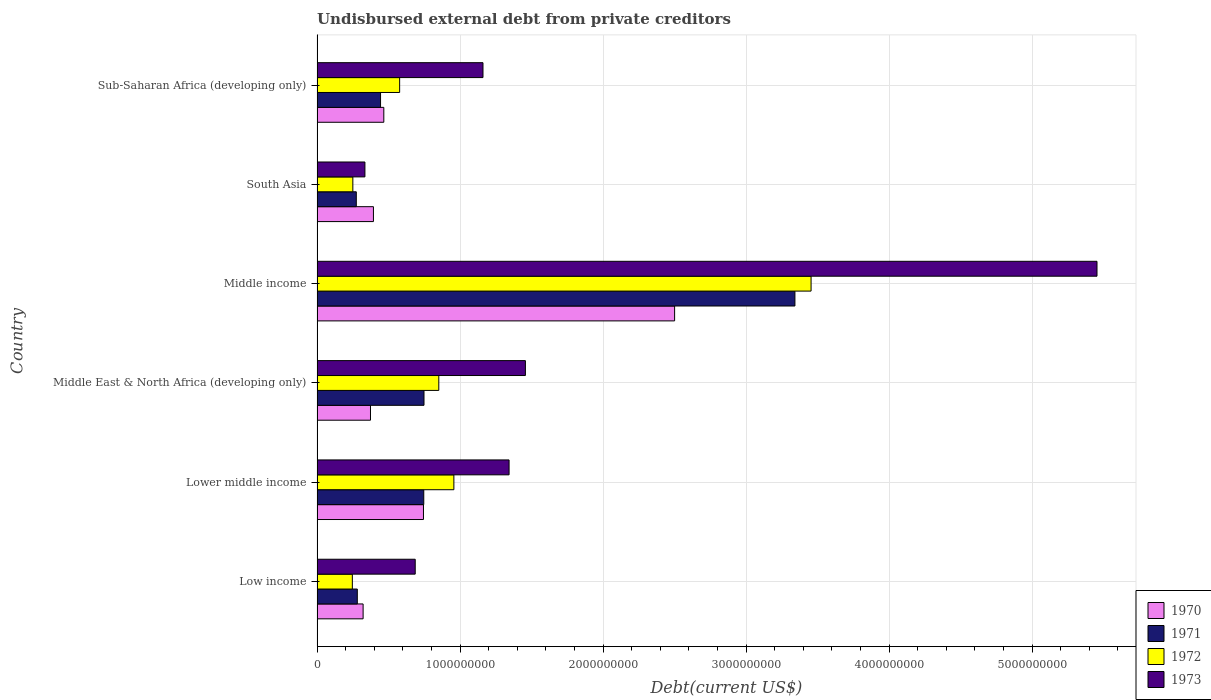Are the number of bars per tick equal to the number of legend labels?
Ensure brevity in your answer.  Yes. How many bars are there on the 1st tick from the top?
Offer a very short reply. 4. How many bars are there on the 4th tick from the bottom?
Your answer should be very brief. 4. What is the label of the 5th group of bars from the top?
Ensure brevity in your answer.  Lower middle income. What is the total debt in 1973 in South Asia?
Keep it short and to the point. 3.35e+08. Across all countries, what is the maximum total debt in 1971?
Give a very brief answer. 3.34e+09. Across all countries, what is the minimum total debt in 1972?
Make the answer very short. 2.47e+08. In which country was the total debt in 1972 minimum?
Your answer should be compact. Low income. What is the total total debt in 1971 in the graph?
Make the answer very short. 5.84e+09. What is the difference between the total debt in 1973 in Low income and that in Middle income?
Your response must be concise. -4.77e+09. What is the difference between the total debt in 1972 in Lower middle income and the total debt in 1970 in Middle income?
Offer a very short reply. -1.54e+09. What is the average total debt in 1973 per country?
Make the answer very short. 1.74e+09. What is the difference between the total debt in 1973 and total debt in 1970 in Sub-Saharan Africa (developing only)?
Offer a terse response. 6.94e+08. In how many countries, is the total debt in 1973 greater than 2800000000 US$?
Offer a very short reply. 1. What is the ratio of the total debt in 1973 in Lower middle income to that in Sub-Saharan Africa (developing only)?
Make the answer very short. 1.16. Is the difference between the total debt in 1973 in Middle East & North Africa (developing only) and Sub-Saharan Africa (developing only) greater than the difference between the total debt in 1970 in Middle East & North Africa (developing only) and Sub-Saharan Africa (developing only)?
Give a very brief answer. Yes. What is the difference between the highest and the second highest total debt in 1973?
Your answer should be very brief. 4.00e+09. What is the difference between the highest and the lowest total debt in 1972?
Your response must be concise. 3.21e+09. In how many countries, is the total debt in 1972 greater than the average total debt in 1972 taken over all countries?
Your answer should be compact. 1. Is the sum of the total debt in 1970 in Middle income and South Asia greater than the maximum total debt in 1971 across all countries?
Offer a very short reply. No. What does the 2nd bar from the bottom in Middle income represents?
Your response must be concise. 1971. What is the difference between two consecutive major ticks on the X-axis?
Offer a very short reply. 1.00e+09. Where does the legend appear in the graph?
Your answer should be very brief. Bottom right. How many legend labels are there?
Your answer should be very brief. 4. How are the legend labels stacked?
Make the answer very short. Vertical. What is the title of the graph?
Give a very brief answer. Undisbursed external debt from private creditors. What is the label or title of the X-axis?
Keep it short and to the point. Debt(current US$). What is the Debt(current US$) of 1970 in Low income?
Make the answer very short. 3.22e+08. What is the Debt(current US$) of 1971 in Low income?
Your response must be concise. 2.82e+08. What is the Debt(current US$) in 1972 in Low income?
Provide a short and direct response. 2.47e+08. What is the Debt(current US$) in 1973 in Low income?
Keep it short and to the point. 6.86e+08. What is the Debt(current US$) in 1970 in Lower middle income?
Ensure brevity in your answer.  7.44e+08. What is the Debt(current US$) of 1971 in Lower middle income?
Offer a very short reply. 7.46e+08. What is the Debt(current US$) in 1972 in Lower middle income?
Make the answer very short. 9.57e+08. What is the Debt(current US$) in 1973 in Lower middle income?
Your response must be concise. 1.34e+09. What is the Debt(current US$) in 1970 in Middle East & North Africa (developing only)?
Provide a short and direct response. 3.74e+08. What is the Debt(current US$) in 1971 in Middle East & North Africa (developing only)?
Provide a succinct answer. 7.48e+08. What is the Debt(current US$) in 1972 in Middle East & North Africa (developing only)?
Offer a very short reply. 8.51e+08. What is the Debt(current US$) in 1973 in Middle East & North Africa (developing only)?
Your answer should be compact. 1.46e+09. What is the Debt(current US$) of 1970 in Middle income?
Your response must be concise. 2.50e+09. What is the Debt(current US$) in 1971 in Middle income?
Provide a short and direct response. 3.34e+09. What is the Debt(current US$) of 1972 in Middle income?
Ensure brevity in your answer.  3.45e+09. What is the Debt(current US$) in 1973 in Middle income?
Provide a short and direct response. 5.45e+09. What is the Debt(current US$) of 1970 in South Asia?
Offer a very short reply. 3.94e+08. What is the Debt(current US$) of 1971 in South Asia?
Your response must be concise. 2.74e+08. What is the Debt(current US$) of 1972 in South Asia?
Your response must be concise. 2.50e+08. What is the Debt(current US$) of 1973 in South Asia?
Your response must be concise. 3.35e+08. What is the Debt(current US$) in 1970 in Sub-Saharan Africa (developing only)?
Offer a terse response. 4.67e+08. What is the Debt(current US$) of 1971 in Sub-Saharan Africa (developing only)?
Your response must be concise. 4.44e+08. What is the Debt(current US$) of 1972 in Sub-Saharan Africa (developing only)?
Offer a very short reply. 5.77e+08. What is the Debt(current US$) of 1973 in Sub-Saharan Africa (developing only)?
Keep it short and to the point. 1.16e+09. Across all countries, what is the maximum Debt(current US$) of 1970?
Offer a terse response. 2.50e+09. Across all countries, what is the maximum Debt(current US$) of 1971?
Give a very brief answer. 3.34e+09. Across all countries, what is the maximum Debt(current US$) in 1972?
Keep it short and to the point. 3.45e+09. Across all countries, what is the maximum Debt(current US$) of 1973?
Offer a terse response. 5.45e+09. Across all countries, what is the minimum Debt(current US$) in 1970?
Offer a very short reply. 3.22e+08. Across all countries, what is the minimum Debt(current US$) in 1971?
Your answer should be very brief. 2.74e+08. Across all countries, what is the minimum Debt(current US$) in 1972?
Keep it short and to the point. 2.47e+08. Across all countries, what is the minimum Debt(current US$) of 1973?
Provide a short and direct response. 3.35e+08. What is the total Debt(current US$) of 1970 in the graph?
Make the answer very short. 4.80e+09. What is the total Debt(current US$) of 1971 in the graph?
Your answer should be very brief. 5.84e+09. What is the total Debt(current US$) in 1972 in the graph?
Provide a short and direct response. 6.34e+09. What is the total Debt(current US$) of 1973 in the graph?
Offer a very short reply. 1.04e+1. What is the difference between the Debt(current US$) of 1970 in Low income and that in Lower middle income?
Offer a terse response. -4.22e+08. What is the difference between the Debt(current US$) in 1971 in Low income and that in Lower middle income?
Your answer should be compact. -4.65e+08. What is the difference between the Debt(current US$) of 1972 in Low income and that in Lower middle income?
Offer a terse response. -7.10e+08. What is the difference between the Debt(current US$) of 1973 in Low income and that in Lower middle income?
Keep it short and to the point. -6.56e+08. What is the difference between the Debt(current US$) of 1970 in Low income and that in Middle East & North Africa (developing only)?
Ensure brevity in your answer.  -5.15e+07. What is the difference between the Debt(current US$) of 1971 in Low income and that in Middle East & North Africa (developing only)?
Offer a very short reply. -4.66e+08. What is the difference between the Debt(current US$) in 1972 in Low income and that in Middle East & North Africa (developing only)?
Offer a very short reply. -6.05e+08. What is the difference between the Debt(current US$) of 1973 in Low income and that in Middle East & North Africa (developing only)?
Your response must be concise. -7.71e+08. What is the difference between the Debt(current US$) of 1970 in Low income and that in Middle income?
Your response must be concise. -2.18e+09. What is the difference between the Debt(current US$) in 1971 in Low income and that in Middle income?
Your answer should be very brief. -3.06e+09. What is the difference between the Debt(current US$) in 1972 in Low income and that in Middle income?
Your answer should be compact. -3.21e+09. What is the difference between the Debt(current US$) of 1973 in Low income and that in Middle income?
Provide a succinct answer. -4.77e+09. What is the difference between the Debt(current US$) in 1970 in Low income and that in South Asia?
Ensure brevity in your answer.  -7.22e+07. What is the difference between the Debt(current US$) of 1971 in Low income and that in South Asia?
Your answer should be compact. 7.14e+06. What is the difference between the Debt(current US$) of 1972 in Low income and that in South Asia?
Ensure brevity in your answer.  -3.44e+06. What is the difference between the Debt(current US$) in 1973 in Low income and that in South Asia?
Give a very brief answer. 3.52e+08. What is the difference between the Debt(current US$) in 1970 in Low income and that in Sub-Saharan Africa (developing only)?
Offer a very short reply. -1.45e+08. What is the difference between the Debt(current US$) in 1971 in Low income and that in Sub-Saharan Africa (developing only)?
Provide a succinct answer. -1.63e+08. What is the difference between the Debt(current US$) in 1972 in Low income and that in Sub-Saharan Africa (developing only)?
Offer a very short reply. -3.31e+08. What is the difference between the Debt(current US$) of 1973 in Low income and that in Sub-Saharan Africa (developing only)?
Ensure brevity in your answer.  -4.74e+08. What is the difference between the Debt(current US$) in 1970 in Lower middle income and that in Middle East & North Africa (developing only)?
Make the answer very short. 3.71e+08. What is the difference between the Debt(current US$) of 1971 in Lower middle income and that in Middle East & North Africa (developing only)?
Keep it short and to the point. -1.62e+06. What is the difference between the Debt(current US$) of 1972 in Lower middle income and that in Middle East & North Africa (developing only)?
Provide a succinct answer. 1.05e+08. What is the difference between the Debt(current US$) in 1973 in Lower middle income and that in Middle East & North Africa (developing only)?
Your answer should be very brief. -1.14e+08. What is the difference between the Debt(current US$) of 1970 in Lower middle income and that in Middle income?
Offer a terse response. -1.76e+09. What is the difference between the Debt(current US$) in 1971 in Lower middle income and that in Middle income?
Make the answer very short. -2.60e+09. What is the difference between the Debt(current US$) in 1972 in Lower middle income and that in Middle income?
Your response must be concise. -2.50e+09. What is the difference between the Debt(current US$) in 1973 in Lower middle income and that in Middle income?
Provide a succinct answer. -4.11e+09. What is the difference between the Debt(current US$) in 1970 in Lower middle income and that in South Asia?
Ensure brevity in your answer.  3.50e+08. What is the difference between the Debt(current US$) in 1971 in Lower middle income and that in South Asia?
Keep it short and to the point. 4.72e+08. What is the difference between the Debt(current US$) in 1972 in Lower middle income and that in South Asia?
Provide a short and direct response. 7.07e+08. What is the difference between the Debt(current US$) of 1973 in Lower middle income and that in South Asia?
Offer a very short reply. 1.01e+09. What is the difference between the Debt(current US$) in 1970 in Lower middle income and that in Sub-Saharan Africa (developing only)?
Give a very brief answer. 2.77e+08. What is the difference between the Debt(current US$) of 1971 in Lower middle income and that in Sub-Saharan Africa (developing only)?
Provide a succinct answer. 3.02e+08. What is the difference between the Debt(current US$) in 1972 in Lower middle income and that in Sub-Saharan Africa (developing only)?
Make the answer very short. 3.79e+08. What is the difference between the Debt(current US$) of 1973 in Lower middle income and that in Sub-Saharan Africa (developing only)?
Your answer should be very brief. 1.82e+08. What is the difference between the Debt(current US$) of 1970 in Middle East & North Africa (developing only) and that in Middle income?
Provide a succinct answer. -2.13e+09. What is the difference between the Debt(current US$) of 1971 in Middle East & North Africa (developing only) and that in Middle income?
Provide a short and direct response. -2.59e+09. What is the difference between the Debt(current US$) of 1972 in Middle East & North Africa (developing only) and that in Middle income?
Offer a terse response. -2.60e+09. What is the difference between the Debt(current US$) in 1973 in Middle East & North Africa (developing only) and that in Middle income?
Provide a short and direct response. -4.00e+09. What is the difference between the Debt(current US$) in 1970 in Middle East & North Africa (developing only) and that in South Asia?
Make the answer very short. -2.07e+07. What is the difference between the Debt(current US$) of 1971 in Middle East & North Africa (developing only) and that in South Asia?
Keep it short and to the point. 4.74e+08. What is the difference between the Debt(current US$) of 1972 in Middle East & North Africa (developing only) and that in South Asia?
Offer a terse response. 6.01e+08. What is the difference between the Debt(current US$) of 1973 in Middle East & North Africa (developing only) and that in South Asia?
Your answer should be very brief. 1.12e+09. What is the difference between the Debt(current US$) in 1970 in Middle East & North Africa (developing only) and that in Sub-Saharan Africa (developing only)?
Offer a terse response. -9.32e+07. What is the difference between the Debt(current US$) in 1971 in Middle East & North Africa (developing only) and that in Sub-Saharan Africa (developing only)?
Your answer should be very brief. 3.04e+08. What is the difference between the Debt(current US$) in 1972 in Middle East & North Africa (developing only) and that in Sub-Saharan Africa (developing only)?
Provide a short and direct response. 2.74e+08. What is the difference between the Debt(current US$) in 1973 in Middle East & North Africa (developing only) and that in Sub-Saharan Africa (developing only)?
Your answer should be very brief. 2.97e+08. What is the difference between the Debt(current US$) of 1970 in Middle income and that in South Asia?
Offer a very short reply. 2.11e+09. What is the difference between the Debt(current US$) of 1971 in Middle income and that in South Asia?
Give a very brief answer. 3.07e+09. What is the difference between the Debt(current US$) of 1972 in Middle income and that in South Asia?
Your answer should be compact. 3.20e+09. What is the difference between the Debt(current US$) in 1973 in Middle income and that in South Asia?
Provide a short and direct response. 5.12e+09. What is the difference between the Debt(current US$) of 1970 in Middle income and that in Sub-Saharan Africa (developing only)?
Your answer should be compact. 2.03e+09. What is the difference between the Debt(current US$) in 1971 in Middle income and that in Sub-Saharan Africa (developing only)?
Provide a short and direct response. 2.90e+09. What is the difference between the Debt(current US$) of 1972 in Middle income and that in Sub-Saharan Africa (developing only)?
Provide a short and direct response. 2.88e+09. What is the difference between the Debt(current US$) of 1973 in Middle income and that in Sub-Saharan Africa (developing only)?
Your answer should be compact. 4.29e+09. What is the difference between the Debt(current US$) of 1970 in South Asia and that in Sub-Saharan Africa (developing only)?
Your answer should be very brief. -7.26e+07. What is the difference between the Debt(current US$) of 1971 in South Asia and that in Sub-Saharan Africa (developing only)?
Give a very brief answer. -1.70e+08. What is the difference between the Debt(current US$) of 1972 in South Asia and that in Sub-Saharan Africa (developing only)?
Keep it short and to the point. -3.27e+08. What is the difference between the Debt(current US$) of 1973 in South Asia and that in Sub-Saharan Africa (developing only)?
Provide a short and direct response. -8.26e+08. What is the difference between the Debt(current US$) in 1970 in Low income and the Debt(current US$) in 1971 in Lower middle income?
Provide a short and direct response. -4.24e+08. What is the difference between the Debt(current US$) of 1970 in Low income and the Debt(current US$) of 1972 in Lower middle income?
Make the answer very short. -6.35e+08. What is the difference between the Debt(current US$) of 1970 in Low income and the Debt(current US$) of 1973 in Lower middle income?
Your answer should be compact. -1.02e+09. What is the difference between the Debt(current US$) in 1971 in Low income and the Debt(current US$) in 1972 in Lower middle income?
Provide a short and direct response. -6.75e+08. What is the difference between the Debt(current US$) in 1971 in Low income and the Debt(current US$) in 1973 in Lower middle income?
Keep it short and to the point. -1.06e+09. What is the difference between the Debt(current US$) in 1972 in Low income and the Debt(current US$) in 1973 in Lower middle income?
Your answer should be compact. -1.10e+09. What is the difference between the Debt(current US$) in 1970 in Low income and the Debt(current US$) in 1971 in Middle East & North Africa (developing only)?
Provide a succinct answer. -4.26e+08. What is the difference between the Debt(current US$) in 1970 in Low income and the Debt(current US$) in 1972 in Middle East & North Africa (developing only)?
Provide a short and direct response. -5.29e+08. What is the difference between the Debt(current US$) in 1970 in Low income and the Debt(current US$) in 1973 in Middle East & North Africa (developing only)?
Offer a terse response. -1.13e+09. What is the difference between the Debt(current US$) of 1971 in Low income and the Debt(current US$) of 1972 in Middle East & North Africa (developing only)?
Your answer should be very brief. -5.70e+08. What is the difference between the Debt(current US$) of 1971 in Low income and the Debt(current US$) of 1973 in Middle East & North Africa (developing only)?
Your answer should be compact. -1.18e+09. What is the difference between the Debt(current US$) of 1972 in Low income and the Debt(current US$) of 1973 in Middle East & North Africa (developing only)?
Your answer should be compact. -1.21e+09. What is the difference between the Debt(current US$) in 1970 in Low income and the Debt(current US$) in 1971 in Middle income?
Give a very brief answer. -3.02e+09. What is the difference between the Debt(current US$) of 1970 in Low income and the Debt(current US$) of 1972 in Middle income?
Make the answer very short. -3.13e+09. What is the difference between the Debt(current US$) of 1970 in Low income and the Debt(current US$) of 1973 in Middle income?
Make the answer very short. -5.13e+09. What is the difference between the Debt(current US$) of 1971 in Low income and the Debt(current US$) of 1972 in Middle income?
Your response must be concise. -3.17e+09. What is the difference between the Debt(current US$) in 1971 in Low income and the Debt(current US$) in 1973 in Middle income?
Make the answer very short. -5.17e+09. What is the difference between the Debt(current US$) in 1972 in Low income and the Debt(current US$) in 1973 in Middle income?
Keep it short and to the point. -5.21e+09. What is the difference between the Debt(current US$) of 1970 in Low income and the Debt(current US$) of 1971 in South Asia?
Provide a short and direct response. 4.77e+07. What is the difference between the Debt(current US$) of 1970 in Low income and the Debt(current US$) of 1972 in South Asia?
Ensure brevity in your answer.  7.18e+07. What is the difference between the Debt(current US$) in 1970 in Low income and the Debt(current US$) in 1973 in South Asia?
Give a very brief answer. -1.27e+07. What is the difference between the Debt(current US$) in 1971 in Low income and the Debt(current US$) in 1972 in South Asia?
Offer a terse response. 3.13e+07. What is the difference between the Debt(current US$) in 1971 in Low income and the Debt(current US$) in 1973 in South Asia?
Make the answer very short. -5.33e+07. What is the difference between the Debt(current US$) of 1972 in Low income and the Debt(current US$) of 1973 in South Asia?
Provide a succinct answer. -8.80e+07. What is the difference between the Debt(current US$) of 1970 in Low income and the Debt(current US$) of 1971 in Sub-Saharan Africa (developing only)?
Your response must be concise. -1.22e+08. What is the difference between the Debt(current US$) of 1970 in Low income and the Debt(current US$) of 1972 in Sub-Saharan Africa (developing only)?
Keep it short and to the point. -2.55e+08. What is the difference between the Debt(current US$) in 1970 in Low income and the Debt(current US$) in 1973 in Sub-Saharan Africa (developing only)?
Keep it short and to the point. -8.38e+08. What is the difference between the Debt(current US$) in 1971 in Low income and the Debt(current US$) in 1972 in Sub-Saharan Africa (developing only)?
Ensure brevity in your answer.  -2.96e+08. What is the difference between the Debt(current US$) of 1971 in Low income and the Debt(current US$) of 1973 in Sub-Saharan Africa (developing only)?
Ensure brevity in your answer.  -8.79e+08. What is the difference between the Debt(current US$) in 1972 in Low income and the Debt(current US$) in 1973 in Sub-Saharan Africa (developing only)?
Your answer should be compact. -9.14e+08. What is the difference between the Debt(current US$) in 1970 in Lower middle income and the Debt(current US$) in 1971 in Middle East & North Africa (developing only)?
Make the answer very short. -3.71e+06. What is the difference between the Debt(current US$) in 1970 in Lower middle income and the Debt(current US$) in 1972 in Middle East & North Africa (developing only)?
Give a very brief answer. -1.07e+08. What is the difference between the Debt(current US$) of 1970 in Lower middle income and the Debt(current US$) of 1973 in Middle East & North Africa (developing only)?
Keep it short and to the point. -7.13e+08. What is the difference between the Debt(current US$) of 1971 in Lower middle income and the Debt(current US$) of 1972 in Middle East & North Africa (developing only)?
Provide a short and direct response. -1.05e+08. What is the difference between the Debt(current US$) in 1971 in Lower middle income and the Debt(current US$) in 1973 in Middle East & North Africa (developing only)?
Offer a terse response. -7.11e+08. What is the difference between the Debt(current US$) in 1972 in Lower middle income and the Debt(current US$) in 1973 in Middle East & North Africa (developing only)?
Your answer should be compact. -5.00e+08. What is the difference between the Debt(current US$) of 1970 in Lower middle income and the Debt(current US$) of 1971 in Middle income?
Your answer should be very brief. -2.60e+09. What is the difference between the Debt(current US$) in 1970 in Lower middle income and the Debt(current US$) in 1972 in Middle income?
Make the answer very short. -2.71e+09. What is the difference between the Debt(current US$) of 1970 in Lower middle income and the Debt(current US$) of 1973 in Middle income?
Provide a short and direct response. -4.71e+09. What is the difference between the Debt(current US$) of 1971 in Lower middle income and the Debt(current US$) of 1972 in Middle income?
Provide a short and direct response. -2.71e+09. What is the difference between the Debt(current US$) of 1971 in Lower middle income and the Debt(current US$) of 1973 in Middle income?
Your answer should be compact. -4.71e+09. What is the difference between the Debt(current US$) in 1972 in Lower middle income and the Debt(current US$) in 1973 in Middle income?
Your response must be concise. -4.50e+09. What is the difference between the Debt(current US$) in 1970 in Lower middle income and the Debt(current US$) in 1971 in South Asia?
Offer a terse response. 4.70e+08. What is the difference between the Debt(current US$) of 1970 in Lower middle income and the Debt(current US$) of 1972 in South Asia?
Offer a terse response. 4.94e+08. What is the difference between the Debt(current US$) of 1970 in Lower middle income and the Debt(current US$) of 1973 in South Asia?
Your answer should be very brief. 4.09e+08. What is the difference between the Debt(current US$) in 1971 in Lower middle income and the Debt(current US$) in 1972 in South Asia?
Offer a very short reply. 4.96e+08. What is the difference between the Debt(current US$) in 1971 in Lower middle income and the Debt(current US$) in 1973 in South Asia?
Give a very brief answer. 4.11e+08. What is the difference between the Debt(current US$) in 1972 in Lower middle income and the Debt(current US$) in 1973 in South Asia?
Provide a succinct answer. 6.22e+08. What is the difference between the Debt(current US$) in 1970 in Lower middle income and the Debt(current US$) in 1971 in Sub-Saharan Africa (developing only)?
Keep it short and to the point. 3.00e+08. What is the difference between the Debt(current US$) of 1970 in Lower middle income and the Debt(current US$) of 1972 in Sub-Saharan Africa (developing only)?
Give a very brief answer. 1.67e+08. What is the difference between the Debt(current US$) in 1970 in Lower middle income and the Debt(current US$) in 1973 in Sub-Saharan Africa (developing only)?
Make the answer very short. -4.16e+08. What is the difference between the Debt(current US$) of 1971 in Lower middle income and the Debt(current US$) of 1972 in Sub-Saharan Africa (developing only)?
Provide a succinct answer. 1.69e+08. What is the difference between the Debt(current US$) in 1971 in Lower middle income and the Debt(current US$) in 1973 in Sub-Saharan Africa (developing only)?
Provide a succinct answer. -4.14e+08. What is the difference between the Debt(current US$) in 1972 in Lower middle income and the Debt(current US$) in 1973 in Sub-Saharan Africa (developing only)?
Your answer should be very brief. -2.04e+08. What is the difference between the Debt(current US$) of 1970 in Middle East & North Africa (developing only) and the Debt(current US$) of 1971 in Middle income?
Keep it short and to the point. -2.97e+09. What is the difference between the Debt(current US$) of 1970 in Middle East & North Africa (developing only) and the Debt(current US$) of 1972 in Middle income?
Provide a succinct answer. -3.08e+09. What is the difference between the Debt(current US$) in 1970 in Middle East & North Africa (developing only) and the Debt(current US$) in 1973 in Middle income?
Give a very brief answer. -5.08e+09. What is the difference between the Debt(current US$) of 1971 in Middle East & North Africa (developing only) and the Debt(current US$) of 1972 in Middle income?
Your answer should be compact. -2.71e+09. What is the difference between the Debt(current US$) of 1971 in Middle East & North Africa (developing only) and the Debt(current US$) of 1973 in Middle income?
Offer a very short reply. -4.71e+09. What is the difference between the Debt(current US$) in 1972 in Middle East & North Africa (developing only) and the Debt(current US$) in 1973 in Middle income?
Your answer should be very brief. -4.60e+09. What is the difference between the Debt(current US$) of 1970 in Middle East & North Africa (developing only) and the Debt(current US$) of 1971 in South Asia?
Your response must be concise. 9.92e+07. What is the difference between the Debt(current US$) in 1970 in Middle East & North Africa (developing only) and the Debt(current US$) in 1972 in South Asia?
Make the answer very short. 1.23e+08. What is the difference between the Debt(current US$) of 1970 in Middle East & North Africa (developing only) and the Debt(current US$) of 1973 in South Asia?
Your answer should be very brief. 3.88e+07. What is the difference between the Debt(current US$) of 1971 in Middle East & North Africa (developing only) and the Debt(current US$) of 1972 in South Asia?
Provide a succinct answer. 4.98e+08. What is the difference between the Debt(current US$) in 1971 in Middle East & North Africa (developing only) and the Debt(current US$) in 1973 in South Asia?
Keep it short and to the point. 4.13e+08. What is the difference between the Debt(current US$) of 1972 in Middle East & North Africa (developing only) and the Debt(current US$) of 1973 in South Asia?
Provide a succinct answer. 5.17e+08. What is the difference between the Debt(current US$) in 1970 in Middle East & North Africa (developing only) and the Debt(current US$) in 1971 in Sub-Saharan Africa (developing only)?
Provide a short and direct response. -7.04e+07. What is the difference between the Debt(current US$) of 1970 in Middle East & North Africa (developing only) and the Debt(current US$) of 1972 in Sub-Saharan Africa (developing only)?
Give a very brief answer. -2.04e+08. What is the difference between the Debt(current US$) of 1970 in Middle East & North Africa (developing only) and the Debt(current US$) of 1973 in Sub-Saharan Africa (developing only)?
Your answer should be very brief. -7.87e+08. What is the difference between the Debt(current US$) in 1971 in Middle East & North Africa (developing only) and the Debt(current US$) in 1972 in Sub-Saharan Africa (developing only)?
Your answer should be compact. 1.70e+08. What is the difference between the Debt(current US$) of 1971 in Middle East & North Africa (developing only) and the Debt(current US$) of 1973 in Sub-Saharan Africa (developing only)?
Make the answer very short. -4.12e+08. What is the difference between the Debt(current US$) of 1972 in Middle East & North Africa (developing only) and the Debt(current US$) of 1973 in Sub-Saharan Africa (developing only)?
Make the answer very short. -3.09e+08. What is the difference between the Debt(current US$) in 1970 in Middle income and the Debt(current US$) in 1971 in South Asia?
Your response must be concise. 2.23e+09. What is the difference between the Debt(current US$) in 1970 in Middle income and the Debt(current US$) in 1972 in South Asia?
Keep it short and to the point. 2.25e+09. What is the difference between the Debt(current US$) in 1970 in Middle income and the Debt(current US$) in 1973 in South Asia?
Your answer should be very brief. 2.17e+09. What is the difference between the Debt(current US$) in 1971 in Middle income and the Debt(current US$) in 1972 in South Asia?
Make the answer very short. 3.09e+09. What is the difference between the Debt(current US$) of 1971 in Middle income and the Debt(current US$) of 1973 in South Asia?
Provide a succinct answer. 3.01e+09. What is the difference between the Debt(current US$) in 1972 in Middle income and the Debt(current US$) in 1973 in South Asia?
Offer a terse response. 3.12e+09. What is the difference between the Debt(current US$) in 1970 in Middle income and the Debt(current US$) in 1971 in Sub-Saharan Africa (developing only)?
Provide a succinct answer. 2.06e+09. What is the difference between the Debt(current US$) of 1970 in Middle income and the Debt(current US$) of 1972 in Sub-Saharan Africa (developing only)?
Provide a succinct answer. 1.92e+09. What is the difference between the Debt(current US$) in 1970 in Middle income and the Debt(current US$) in 1973 in Sub-Saharan Africa (developing only)?
Offer a very short reply. 1.34e+09. What is the difference between the Debt(current US$) in 1971 in Middle income and the Debt(current US$) in 1972 in Sub-Saharan Africa (developing only)?
Keep it short and to the point. 2.76e+09. What is the difference between the Debt(current US$) of 1971 in Middle income and the Debt(current US$) of 1973 in Sub-Saharan Africa (developing only)?
Your answer should be very brief. 2.18e+09. What is the difference between the Debt(current US$) of 1972 in Middle income and the Debt(current US$) of 1973 in Sub-Saharan Africa (developing only)?
Ensure brevity in your answer.  2.29e+09. What is the difference between the Debt(current US$) of 1970 in South Asia and the Debt(current US$) of 1971 in Sub-Saharan Africa (developing only)?
Ensure brevity in your answer.  -4.98e+07. What is the difference between the Debt(current US$) in 1970 in South Asia and the Debt(current US$) in 1972 in Sub-Saharan Africa (developing only)?
Provide a short and direct response. -1.83e+08. What is the difference between the Debt(current US$) of 1970 in South Asia and the Debt(current US$) of 1973 in Sub-Saharan Africa (developing only)?
Your answer should be compact. -7.66e+08. What is the difference between the Debt(current US$) in 1971 in South Asia and the Debt(current US$) in 1972 in Sub-Saharan Africa (developing only)?
Keep it short and to the point. -3.03e+08. What is the difference between the Debt(current US$) of 1971 in South Asia and the Debt(current US$) of 1973 in Sub-Saharan Africa (developing only)?
Give a very brief answer. -8.86e+08. What is the difference between the Debt(current US$) in 1972 in South Asia and the Debt(current US$) in 1973 in Sub-Saharan Africa (developing only)?
Make the answer very short. -9.10e+08. What is the average Debt(current US$) of 1970 per country?
Provide a succinct answer. 8.00e+08. What is the average Debt(current US$) of 1971 per country?
Your response must be concise. 9.73e+08. What is the average Debt(current US$) of 1972 per country?
Provide a succinct answer. 1.06e+09. What is the average Debt(current US$) of 1973 per country?
Make the answer very short. 1.74e+09. What is the difference between the Debt(current US$) of 1970 and Debt(current US$) of 1971 in Low income?
Offer a terse response. 4.06e+07. What is the difference between the Debt(current US$) in 1970 and Debt(current US$) in 1972 in Low income?
Give a very brief answer. 7.53e+07. What is the difference between the Debt(current US$) of 1970 and Debt(current US$) of 1973 in Low income?
Provide a succinct answer. -3.64e+08. What is the difference between the Debt(current US$) of 1971 and Debt(current US$) of 1972 in Low income?
Give a very brief answer. 3.47e+07. What is the difference between the Debt(current US$) of 1971 and Debt(current US$) of 1973 in Low income?
Give a very brief answer. -4.05e+08. What is the difference between the Debt(current US$) in 1972 and Debt(current US$) in 1973 in Low income?
Give a very brief answer. -4.40e+08. What is the difference between the Debt(current US$) of 1970 and Debt(current US$) of 1971 in Lower middle income?
Your response must be concise. -2.10e+06. What is the difference between the Debt(current US$) in 1970 and Debt(current US$) in 1972 in Lower middle income?
Provide a succinct answer. -2.13e+08. What is the difference between the Debt(current US$) in 1970 and Debt(current US$) in 1973 in Lower middle income?
Offer a terse response. -5.99e+08. What is the difference between the Debt(current US$) of 1971 and Debt(current US$) of 1972 in Lower middle income?
Offer a very short reply. -2.11e+08. What is the difference between the Debt(current US$) of 1971 and Debt(current US$) of 1973 in Lower middle income?
Your answer should be very brief. -5.97e+08. What is the difference between the Debt(current US$) of 1972 and Debt(current US$) of 1973 in Lower middle income?
Your answer should be compact. -3.86e+08. What is the difference between the Debt(current US$) of 1970 and Debt(current US$) of 1971 in Middle East & North Africa (developing only)?
Your response must be concise. -3.74e+08. What is the difference between the Debt(current US$) in 1970 and Debt(current US$) in 1972 in Middle East & North Africa (developing only)?
Your response must be concise. -4.78e+08. What is the difference between the Debt(current US$) of 1970 and Debt(current US$) of 1973 in Middle East & North Africa (developing only)?
Keep it short and to the point. -1.08e+09. What is the difference between the Debt(current US$) of 1971 and Debt(current US$) of 1972 in Middle East & North Africa (developing only)?
Ensure brevity in your answer.  -1.04e+08. What is the difference between the Debt(current US$) of 1971 and Debt(current US$) of 1973 in Middle East & North Africa (developing only)?
Keep it short and to the point. -7.09e+08. What is the difference between the Debt(current US$) in 1972 and Debt(current US$) in 1973 in Middle East & North Africa (developing only)?
Provide a succinct answer. -6.06e+08. What is the difference between the Debt(current US$) of 1970 and Debt(current US$) of 1971 in Middle income?
Give a very brief answer. -8.41e+08. What is the difference between the Debt(current US$) in 1970 and Debt(current US$) in 1972 in Middle income?
Ensure brevity in your answer.  -9.54e+08. What is the difference between the Debt(current US$) of 1970 and Debt(current US$) of 1973 in Middle income?
Make the answer very short. -2.95e+09. What is the difference between the Debt(current US$) of 1971 and Debt(current US$) of 1972 in Middle income?
Make the answer very short. -1.13e+08. What is the difference between the Debt(current US$) in 1971 and Debt(current US$) in 1973 in Middle income?
Ensure brevity in your answer.  -2.11e+09. What is the difference between the Debt(current US$) in 1972 and Debt(current US$) in 1973 in Middle income?
Offer a terse response. -2.00e+09. What is the difference between the Debt(current US$) of 1970 and Debt(current US$) of 1971 in South Asia?
Ensure brevity in your answer.  1.20e+08. What is the difference between the Debt(current US$) in 1970 and Debt(current US$) in 1972 in South Asia?
Ensure brevity in your answer.  1.44e+08. What is the difference between the Debt(current US$) of 1970 and Debt(current US$) of 1973 in South Asia?
Give a very brief answer. 5.95e+07. What is the difference between the Debt(current US$) in 1971 and Debt(current US$) in 1972 in South Asia?
Your answer should be compact. 2.41e+07. What is the difference between the Debt(current US$) of 1971 and Debt(current US$) of 1973 in South Asia?
Provide a succinct answer. -6.04e+07. What is the difference between the Debt(current US$) in 1972 and Debt(current US$) in 1973 in South Asia?
Make the answer very short. -8.45e+07. What is the difference between the Debt(current US$) in 1970 and Debt(current US$) in 1971 in Sub-Saharan Africa (developing only)?
Provide a short and direct response. 2.28e+07. What is the difference between the Debt(current US$) of 1970 and Debt(current US$) of 1972 in Sub-Saharan Africa (developing only)?
Offer a terse response. -1.11e+08. What is the difference between the Debt(current US$) in 1970 and Debt(current US$) in 1973 in Sub-Saharan Africa (developing only)?
Ensure brevity in your answer.  -6.94e+08. What is the difference between the Debt(current US$) in 1971 and Debt(current US$) in 1972 in Sub-Saharan Africa (developing only)?
Ensure brevity in your answer.  -1.33e+08. What is the difference between the Debt(current US$) in 1971 and Debt(current US$) in 1973 in Sub-Saharan Africa (developing only)?
Make the answer very short. -7.16e+08. What is the difference between the Debt(current US$) in 1972 and Debt(current US$) in 1973 in Sub-Saharan Africa (developing only)?
Provide a short and direct response. -5.83e+08. What is the ratio of the Debt(current US$) of 1970 in Low income to that in Lower middle income?
Your answer should be very brief. 0.43. What is the ratio of the Debt(current US$) in 1971 in Low income to that in Lower middle income?
Your response must be concise. 0.38. What is the ratio of the Debt(current US$) in 1972 in Low income to that in Lower middle income?
Provide a succinct answer. 0.26. What is the ratio of the Debt(current US$) of 1973 in Low income to that in Lower middle income?
Provide a short and direct response. 0.51. What is the ratio of the Debt(current US$) of 1970 in Low income to that in Middle East & North Africa (developing only)?
Give a very brief answer. 0.86. What is the ratio of the Debt(current US$) of 1971 in Low income to that in Middle East & North Africa (developing only)?
Keep it short and to the point. 0.38. What is the ratio of the Debt(current US$) in 1972 in Low income to that in Middle East & North Africa (developing only)?
Offer a terse response. 0.29. What is the ratio of the Debt(current US$) of 1973 in Low income to that in Middle East & North Africa (developing only)?
Your answer should be compact. 0.47. What is the ratio of the Debt(current US$) of 1970 in Low income to that in Middle income?
Your answer should be compact. 0.13. What is the ratio of the Debt(current US$) in 1971 in Low income to that in Middle income?
Keep it short and to the point. 0.08. What is the ratio of the Debt(current US$) in 1972 in Low income to that in Middle income?
Provide a succinct answer. 0.07. What is the ratio of the Debt(current US$) in 1973 in Low income to that in Middle income?
Make the answer very short. 0.13. What is the ratio of the Debt(current US$) in 1970 in Low income to that in South Asia?
Your answer should be compact. 0.82. What is the ratio of the Debt(current US$) of 1972 in Low income to that in South Asia?
Your response must be concise. 0.99. What is the ratio of the Debt(current US$) in 1973 in Low income to that in South Asia?
Provide a succinct answer. 2.05. What is the ratio of the Debt(current US$) in 1970 in Low income to that in Sub-Saharan Africa (developing only)?
Make the answer very short. 0.69. What is the ratio of the Debt(current US$) of 1971 in Low income to that in Sub-Saharan Africa (developing only)?
Your answer should be very brief. 0.63. What is the ratio of the Debt(current US$) of 1972 in Low income to that in Sub-Saharan Africa (developing only)?
Ensure brevity in your answer.  0.43. What is the ratio of the Debt(current US$) in 1973 in Low income to that in Sub-Saharan Africa (developing only)?
Offer a very short reply. 0.59. What is the ratio of the Debt(current US$) of 1970 in Lower middle income to that in Middle East & North Africa (developing only)?
Give a very brief answer. 1.99. What is the ratio of the Debt(current US$) in 1972 in Lower middle income to that in Middle East & North Africa (developing only)?
Ensure brevity in your answer.  1.12. What is the ratio of the Debt(current US$) in 1973 in Lower middle income to that in Middle East & North Africa (developing only)?
Your response must be concise. 0.92. What is the ratio of the Debt(current US$) in 1970 in Lower middle income to that in Middle income?
Provide a short and direct response. 0.3. What is the ratio of the Debt(current US$) in 1971 in Lower middle income to that in Middle income?
Offer a very short reply. 0.22. What is the ratio of the Debt(current US$) of 1972 in Lower middle income to that in Middle income?
Ensure brevity in your answer.  0.28. What is the ratio of the Debt(current US$) of 1973 in Lower middle income to that in Middle income?
Your answer should be compact. 0.25. What is the ratio of the Debt(current US$) in 1970 in Lower middle income to that in South Asia?
Offer a terse response. 1.89. What is the ratio of the Debt(current US$) of 1971 in Lower middle income to that in South Asia?
Ensure brevity in your answer.  2.72. What is the ratio of the Debt(current US$) in 1972 in Lower middle income to that in South Asia?
Your answer should be compact. 3.82. What is the ratio of the Debt(current US$) of 1973 in Lower middle income to that in South Asia?
Give a very brief answer. 4.01. What is the ratio of the Debt(current US$) of 1970 in Lower middle income to that in Sub-Saharan Africa (developing only)?
Ensure brevity in your answer.  1.59. What is the ratio of the Debt(current US$) in 1971 in Lower middle income to that in Sub-Saharan Africa (developing only)?
Ensure brevity in your answer.  1.68. What is the ratio of the Debt(current US$) in 1972 in Lower middle income to that in Sub-Saharan Africa (developing only)?
Make the answer very short. 1.66. What is the ratio of the Debt(current US$) in 1973 in Lower middle income to that in Sub-Saharan Africa (developing only)?
Keep it short and to the point. 1.16. What is the ratio of the Debt(current US$) of 1970 in Middle East & North Africa (developing only) to that in Middle income?
Offer a very short reply. 0.15. What is the ratio of the Debt(current US$) in 1971 in Middle East & North Africa (developing only) to that in Middle income?
Provide a succinct answer. 0.22. What is the ratio of the Debt(current US$) of 1972 in Middle East & North Africa (developing only) to that in Middle income?
Offer a terse response. 0.25. What is the ratio of the Debt(current US$) in 1973 in Middle East & North Africa (developing only) to that in Middle income?
Your response must be concise. 0.27. What is the ratio of the Debt(current US$) of 1970 in Middle East & North Africa (developing only) to that in South Asia?
Make the answer very short. 0.95. What is the ratio of the Debt(current US$) in 1971 in Middle East & North Africa (developing only) to that in South Asia?
Your answer should be compact. 2.73. What is the ratio of the Debt(current US$) of 1972 in Middle East & North Africa (developing only) to that in South Asia?
Your answer should be compact. 3.4. What is the ratio of the Debt(current US$) in 1973 in Middle East & North Africa (developing only) to that in South Asia?
Offer a terse response. 4.35. What is the ratio of the Debt(current US$) in 1970 in Middle East & North Africa (developing only) to that in Sub-Saharan Africa (developing only)?
Your answer should be very brief. 0.8. What is the ratio of the Debt(current US$) in 1971 in Middle East & North Africa (developing only) to that in Sub-Saharan Africa (developing only)?
Offer a terse response. 1.68. What is the ratio of the Debt(current US$) of 1972 in Middle East & North Africa (developing only) to that in Sub-Saharan Africa (developing only)?
Provide a succinct answer. 1.47. What is the ratio of the Debt(current US$) in 1973 in Middle East & North Africa (developing only) to that in Sub-Saharan Africa (developing only)?
Your response must be concise. 1.26. What is the ratio of the Debt(current US$) of 1970 in Middle income to that in South Asia?
Your response must be concise. 6.34. What is the ratio of the Debt(current US$) in 1971 in Middle income to that in South Asia?
Provide a short and direct response. 12.18. What is the ratio of the Debt(current US$) in 1972 in Middle income to that in South Asia?
Offer a very short reply. 13.8. What is the ratio of the Debt(current US$) of 1973 in Middle income to that in South Asia?
Ensure brevity in your answer.  16.29. What is the ratio of the Debt(current US$) of 1970 in Middle income to that in Sub-Saharan Africa (developing only)?
Make the answer very short. 5.36. What is the ratio of the Debt(current US$) of 1971 in Middle income to that in Sub-Saharan Africa (developing only)?
Provide a succinct answer. 7.53. What is the ratio of the Debt(current US$) of 1972 in Middle income to that in Sub-Saharan Africa (developing only)?
Keep it short and to the point. 5.98. What is the ratio of the Debt(current US$) in 1973 in Middle income to that in Sub-Saharan Africa (developing only)?
Offer a terse response. 4.7. What is the ratio of the Debt(current US$) of 1970 in South Asia to that in Sub-Saharan Africa (developing only)?
Give a very brief answer. 0.84. What is the ratio of the Debt(current US$) of 1971 in South Asia to that in Sub-Saharan Africa (developing only)?
Make the answer very short. 0.62. What is the ratio of the Debt(current US$) of 1972 in South Asia to that in Sub-Saharan Africa (developing only)?
Ensure brevity in your answer.  0.43. What is the ratio of the Debt(current US$) in 1973 in South Asia to that in Sub-Saharan Africa (developing only)?
Your answer should be compact. 0.29. What is the difference between the highest and the second highest Debt(current US$) in 1970?
Ensure brevity in your answer.  1.76e+09. What is the difference between the highest and the second highest Debt(current US$) in 1971?
Give a very brief answer. 2.59e+09. What is the difference between the highest and the second highest Debt(current US$) in 1972?
Your answer should be compact. 2.50e+09. What is the difference between the highest and the second highest Debt(current US$) in 1973?
Offer a terse response. 4.00e+09. What is the difference between the highest and the lowest Debt(current US$) in 1970?
Give a very brief answer. 2.18e+09. What is the difference between the highest and the lowest Debt(current US$) of 1971?
Your response must be concise. 3.07e+09. What is the difference between the highest and the lowest Debt(current US$) of 1972?
Your answer should be compact. 3.21e+09. What is the difference between the highest and the lowest Debt(current US$) in 1973?
Provide a short and direct response. 5.12e+09. 